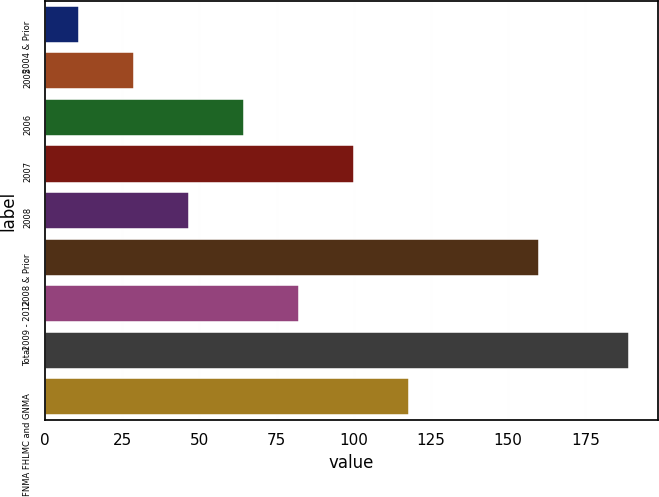Convert chart. <chart><loc_0><loc_0><loc_500><loc_500><bar_chart><fcel>2004 & Prior<fcel>2005<fcel>2006<fcel>2007<fcel>2008<fcel>2008 & Prior<fcel>2009 - 2012<fcel>Total<fcel>FNMA FHLMC and GNMA<nl><fcel>11<fcel>28.8<fcel>64.4<fcel>100<fcel>46.6<fcel>160<fcel>82.2<fcel>189<fcel>117.8<nl></chart> 